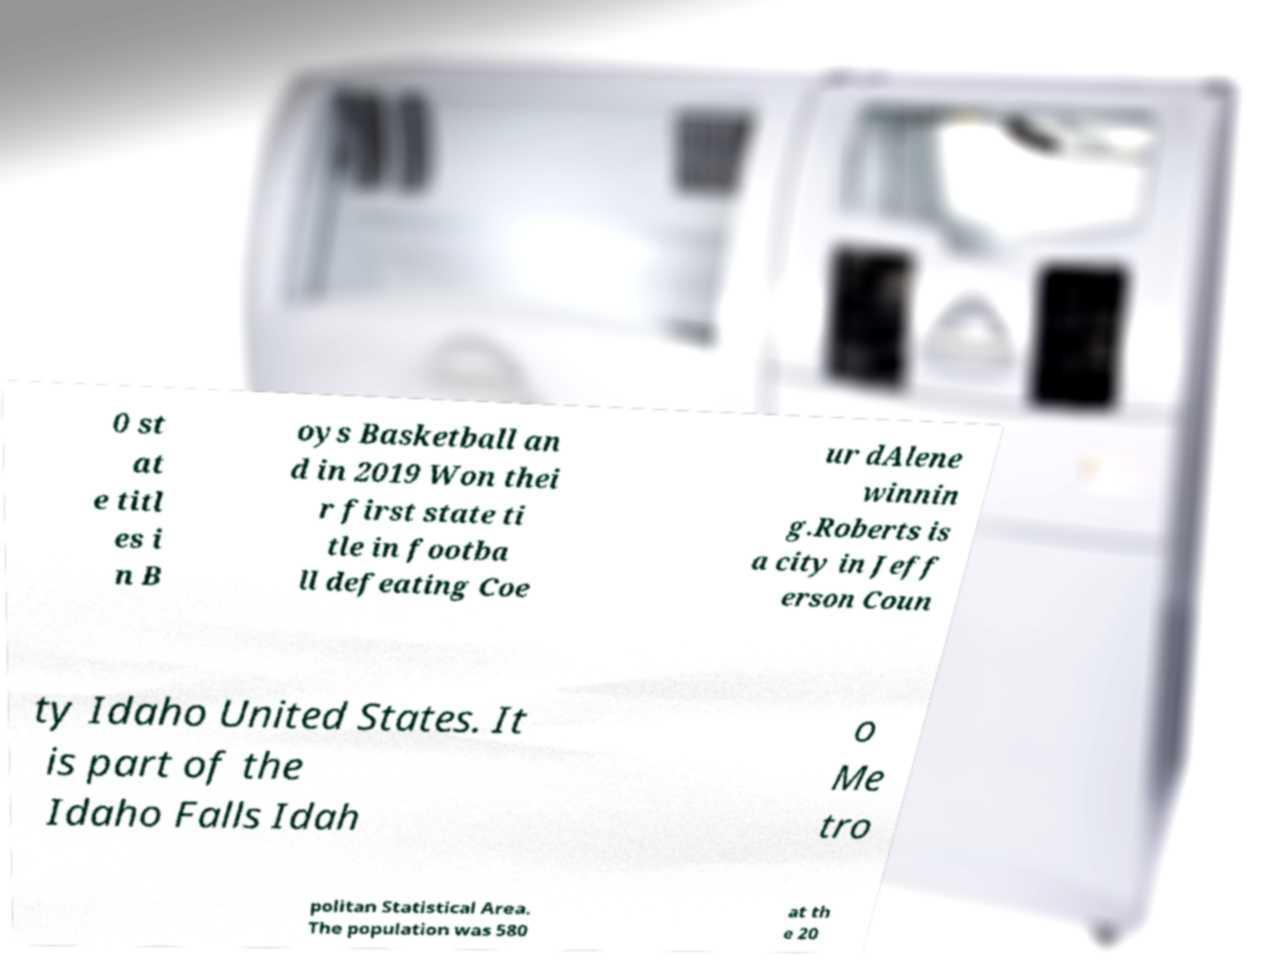Could you assist in decoding the text presented in this image and type it out clearly? 0 st at e titl es i n B oys Basketball an d in 2019 Won thei r first state ti tle in footba ll defeating Coe ur dAlene winnin g.Roberts is a city in Jeff erson Coun ty Idaho United States. It is part of the Idaho Falls Idah o Me tro politan Statistical Area. The population was 580 at th e 20 